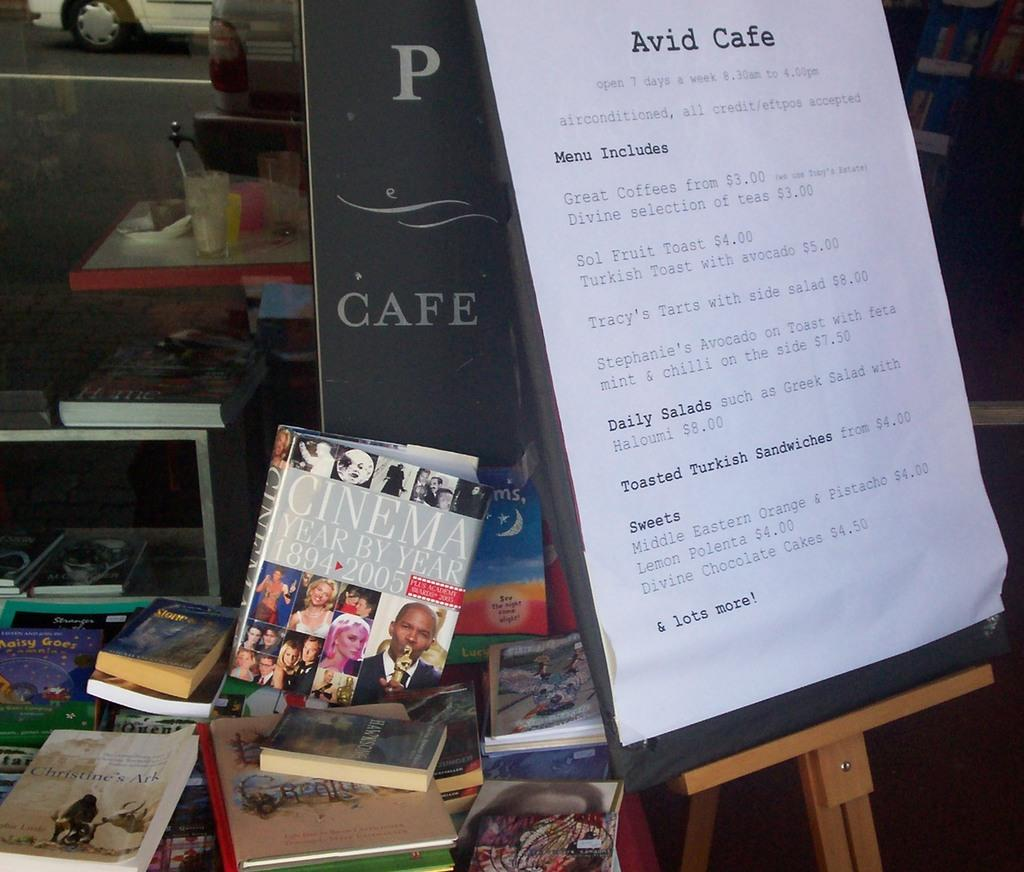<image>
Share a concise interpretation of the image provided. A large menu for the Avid Cafe next to a pile of books. 